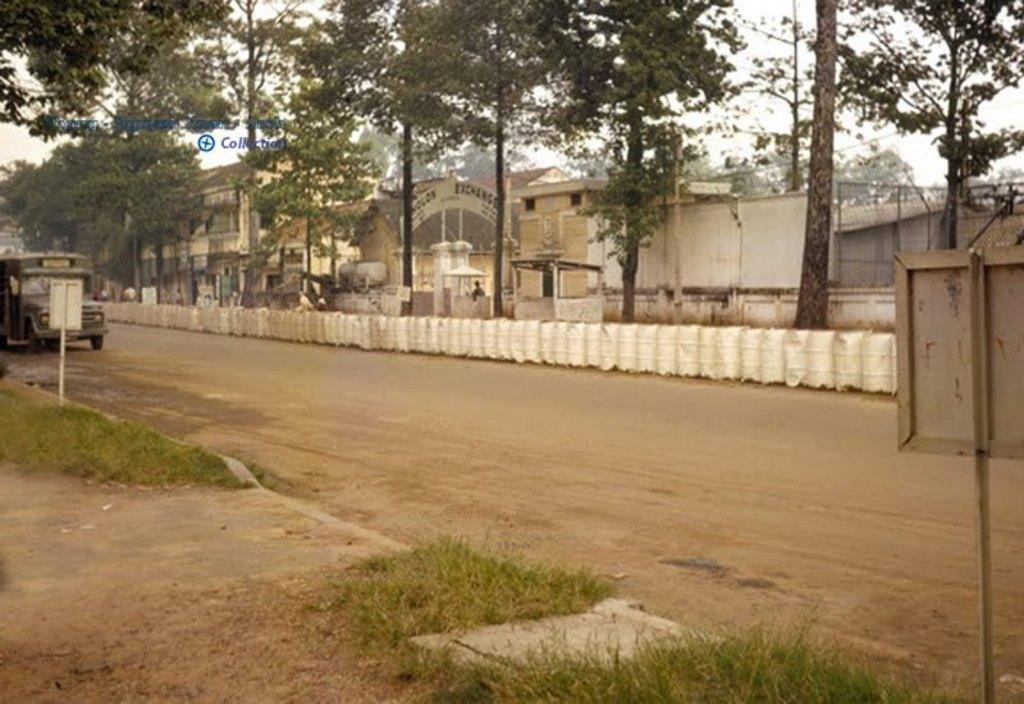How would you summarize this image in a sentence or two? In this image I can see grass, a road in the front and on it I can see a vehicle. In the background I can see number of trees, number of buildings, a board and on it I can see something is written. On the both sides of the image I can see two poles and two white color boards. I can also see the sky in the background and on the top left side I can see a watermark. 